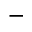<formula> <loc_0><loc_0><loc_500><loc_500>-</formula> 